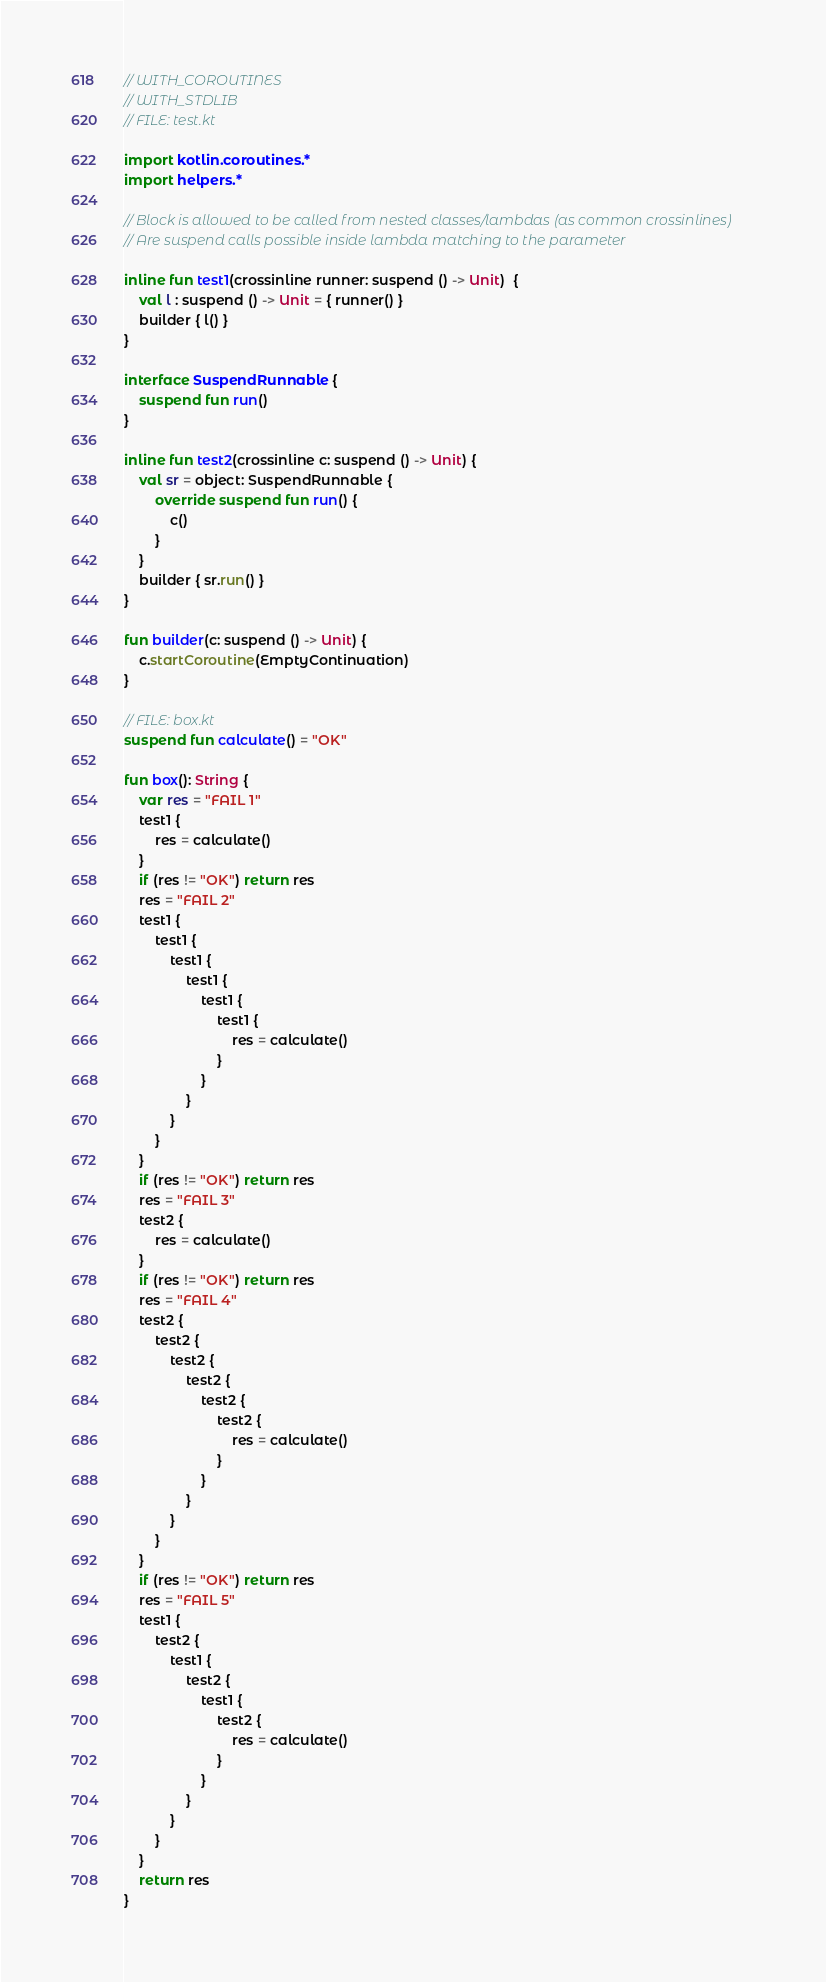<code> <loc_0><loc_0><loc_500><loc_500><_Kotlin_>// WITH_COROUTINES
// WITH_STDLIB
// FILE: test.kt

import kotlin.coroutines.*
import helpers.*

// Block is allowed to be called from nested classes/lambdas (as common crossinlines)
// Are suspend calls possible inside lambda matching to the parameter

inline fun test1(crossinline runner: suspend () -> Unit)  {
    val l : suspend () -> Unit = { runner() }
    builder { l() }
}

interface SuspendRunnable {
    suspend fun run()
}

inline fun test2(crossinline c: suspend () -> Unit) {
    val sr = object: SuspendRunnable {
        override suspend fun run() {
            c()
        }
    }
    builder { sr.run() }
}

fun builder(c: suspend () -> Unit) {
    c.startCoroutine(EmptyContinuation)
}

// FILE: box.kt
suspend fun calculate() = "OK"

fun box(): String {
    var res = "FAIL 1"
    test1 {
        res = calculate()
    }
    if (res != "OK") return res
    res = "FAIL 2"
    test1 {
        test1 {
            test1 {
                test1 {
                    test1 {
                        test1 {
                            res = calculate()
                        }
                    }
                }
            }
        }
    }
    if (res != "OK") return res
    res = "FAIL 3"
    test2 {
        res = calculate()
    }
    if (res != "OK") return res
    res = "FAIL 4"
    test2 {
        test2 {
            test2 {
                test2 {
                    test2 {
                        test2 {
                            res = calculate()
                        }
                    }
                }
            }
        }
    }
    if (res != "OK") return res
    res = "FAIL 5"
    test1 {
        test2 {
            test1 {
                test2 {
                    test1 {
                        test2 {
                            res = calculate()
                        }
                    }
                }
            }
        }
    }
    return res
}
</code> 